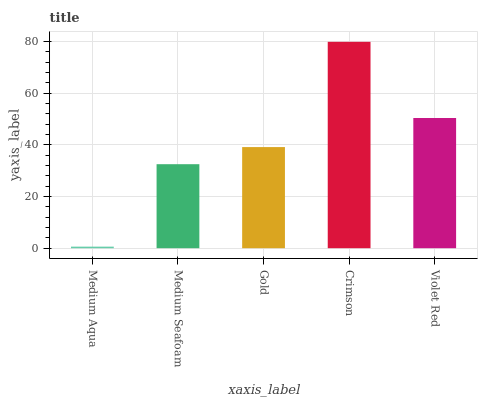Is Medium Aqua the minimum?
Answer yes or no. Yes. Is Crimson the maximum?
Answer yes or no. Yes. Is Medium Seafoam the minimum?
Answer yes or no. No. Is Medium Seafoam the maximum?
Answer yes or no. No. Is Medium Seafoam greater than Medium Aqua?
Answer yes or no. Yes. Is Medium Aqua less than Medium Seafoam?
Answer yes or no. Yes. Is Medium Aqua greater than Medium Seafoam?
Answer yes or no. No. Is Medium Seafoam less than Medium Aqua?
Answer yes or no. No. Is Gold the high median?
Answer yes or no. Yes. Is Gold the low median?
Answer yes or no. Yes. Is Crimson the high median?
Answer yes or no. No. Is Medium Aqua the low median?
Answer yes or no. No. 